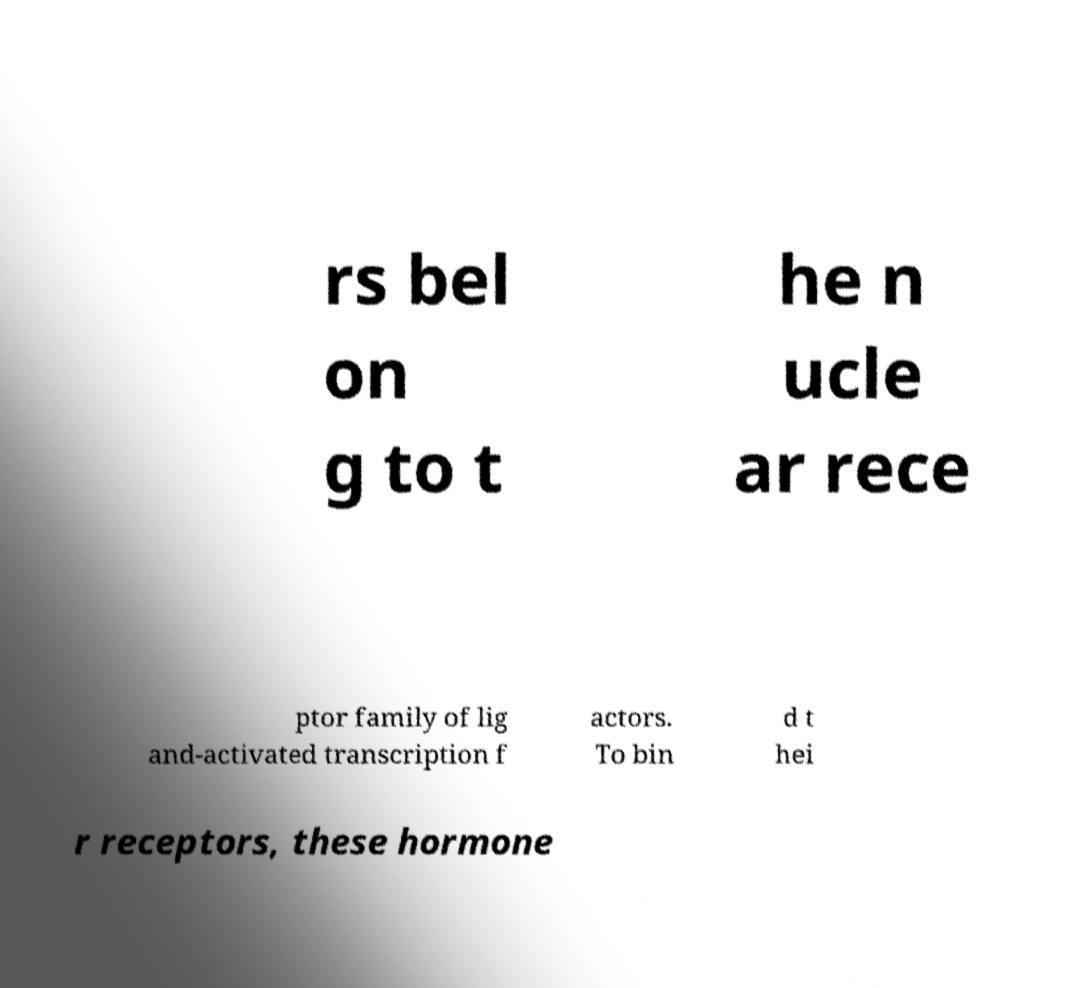Could you assist in decoding the text presented in this image and type it out clearly? rs bel on g to t he n ucle ar rece ptor family of lig and-activated transcription f actors. To bin d t hei r receptors, these hormone 